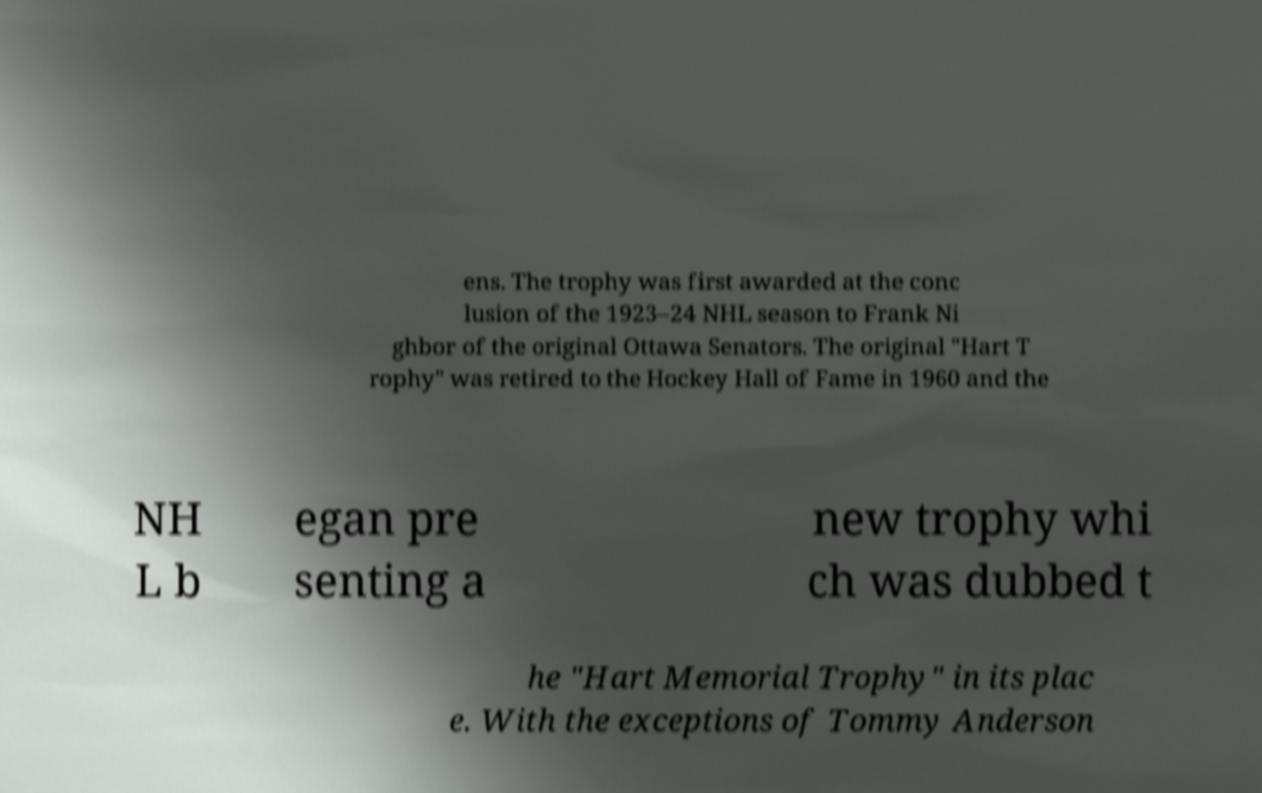Could you assist in decoding the text presented in this image and type it out clearly? ens. The trophy was first awarded at the conc lusion of the 1923–24 NHL season to Frank Ni ghbor of the original Ottawa Senators. The original "Hart T rophy" was retired to the Hockey Hall of Fame in 1960 and the NH L b egan pre senting a new trophy whi ch was dubbed t he "Hart Memorial Trophy" in its plac e. With the exceptions of Tommy Anderson 